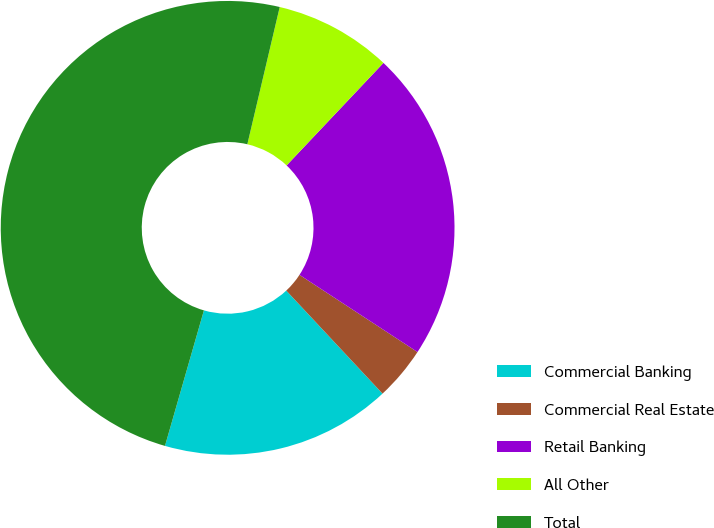Convert chart to OTSL. <chart><loc_0><loc_0><loc_500><loc_500><pie_chart><fcel>Commercial Banking<fcel>Commercial Real Estate<fcel>Retail Banking<fcel>All Other<fcel>Total<nl><fcel>16.41%<fcel>3.82%<fcel>22.17%<fcel>8.36%<fcel>49.23%<nl></chart> 